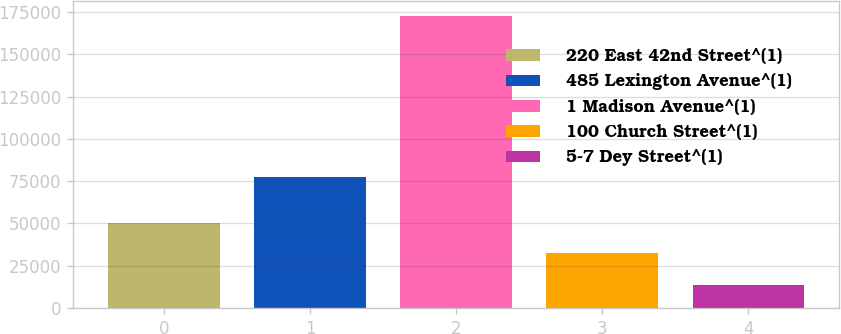<chart> <loc_0><loc_0><loc_500><loc_500><bar_chart><fcel>220 East 42nd Street^(1)<fcel>485 Lexington Avenue^(1)<fcel>1 Madison Avenue^(1)<fcel>100 Church Street^(1)<fcel>5-7 Dey Street^(1)<nl><fcel>50373<fcel>77517<fcel>172641<fcel>32494<fcel>13400<nl></chart> 